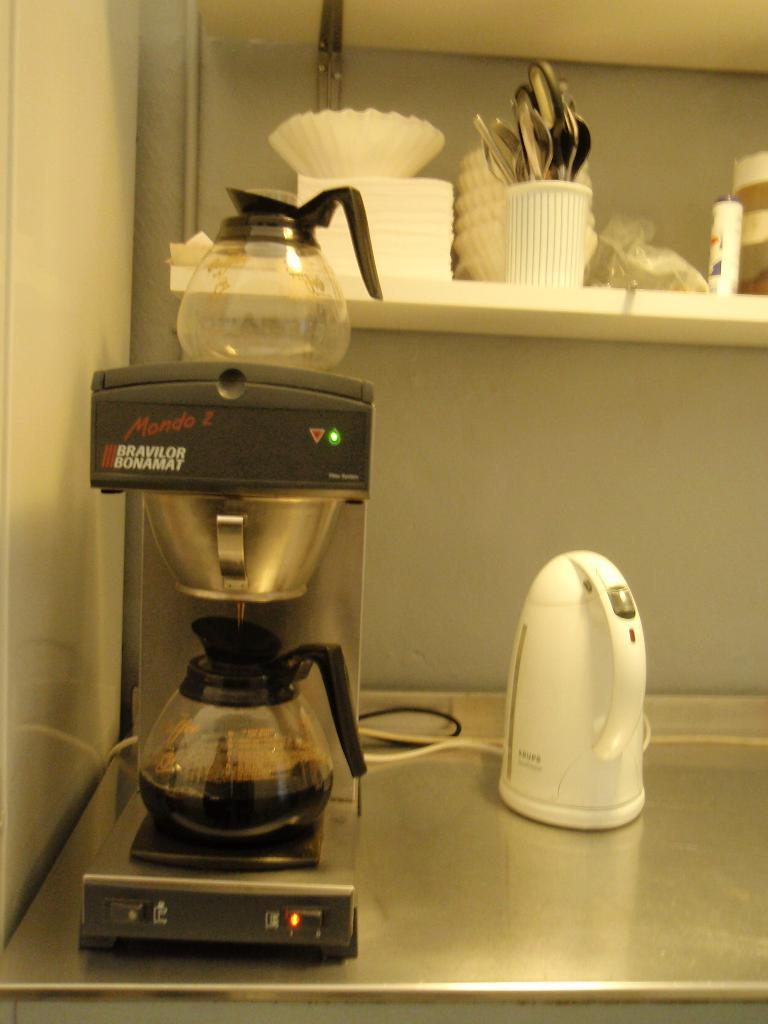<image>
Summarize the visual content of the image. A Mondo 2 coffeemaker and warmer with coffee being poured in 